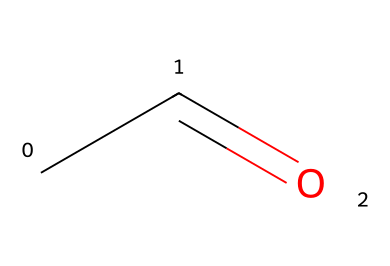What is the name of the chemical represented by the SMILES notation? The SMILES notation CC=O corresponds to acetaldehyde, which is recognized as an aldehyde due to the presence of the -CHO functional group.
Answer: acetaldehyde How many carbon atoms are present in this molecule? In the SMILES representation CC=O, there are two carbon atoms indicated by the two 'C' symbols before the '=O' (which denotes a carbonyl group).
Answer: 2 What is the functional group present in this chemical? The functional group in acetaldehyde is the carbonyl group (C=O), which is characteristic of aldehydes as it is attached to a carbon atom that also has a hydrogen atom.
Answer: carbonyl group How many total hydrogen atoms are in this molecule? The formula of acetaldehyde can be determined as C2H4O, where the carbon atoms (2) and the carbonyl oxygen (1) suggest there are 4 hydrogen atoms attached to the skeletal structure, which comprises one hydrogen for the aldehyde functional group and three attached to the carbon atoms.
Answer: 4 What is the dipole moment of acetaldehyde indicative of? The dipole moment in acetaldehyde signifies its polarity, which arises due to the carbonyl group's strong electronegativity compared to the hydrogen atoms, leading to an uneven electron distribution and thus a polar solvent behavior.
Answer: polarity Why is acetaldehyde categorized as an aldehyde rather than a ketone? Acetaldehyde is categorized as an aldehyde because it has the carbonyl group (C=O) at the end of the carbon chain, whereas ketones feature the carbonyl group located within the carbon chain, demonstrating a distinction based on functional group placement.
Answer: end of the carbon chain 